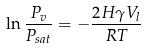Convert formula to latex. <formula><loc_0><loc_0><loc_500><loc_500>\ln \frac { P _ { v } } { P _ { s a t } } = - \frac { 2 H \gamma V _ { l } } { R T }</formula> 